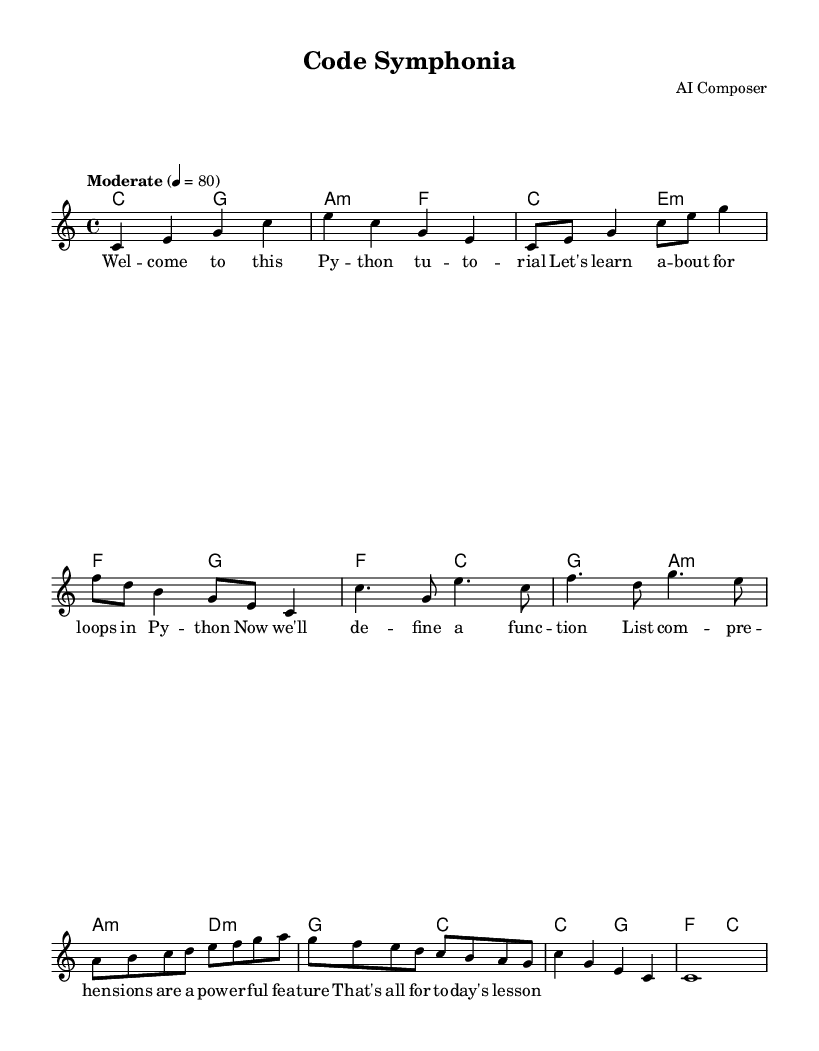What is the key signature of this music? The key signature indicated at the beginning of the score is C major, which has no sharps or flats.
Answer: C major What is the time signature of this music? The time signature is displayed at the beginning of the score, which is 4/4, indicating four beats per measure.
Answer: 4/4 What is the tempo marking of this piece? The tempo marking in the score indicates "Moderate" with a speed of 80 beats per minute, which guides the performance tempo.
Answer: Moderate, 80 How many measures are there in the chorus? By counting the measures specifically in the designated chorus section of the score, there are four measures present.
Answer: 4 What chord is played in the intro? The chord sequence in the intro of the score starts with C major, followed by G major, which establishes the harmonic framework.
Answer: C major, G major What musical element is featured in the bridge? The bridge section includes a range of ascending notes which emphasizes the melodic development and provides contrast to previous sections.
Answer: Ascending melody What unique feature does this work demonstrate that aligns with the experimental style? The combination of lyrics explaining programming concepts within a structured musical form highlights a unique blend of education and art characteristic of experimental music.
Answer: Sampling programming tutorials 